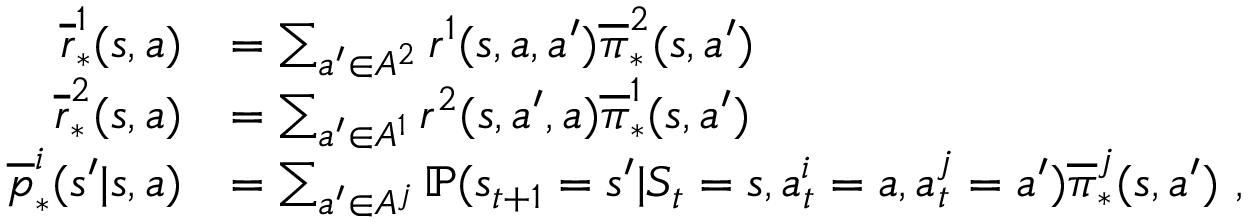<formula> <loc_0><loc_0><loc_500><loc_500>\begin{array} { r l } { \overline { r } _ { * } ^ { 1 } ( s , a ) } & { = \sum _ { a ^ { \prime } \in A ^ { 2 } } r ^ { 1 } ( s , a , a ^ { \prime } ) \overline { \pi } _ { * } ^ { 2 } ( s , a ^ { \prime } ) } \\ { \overline { r } _ { * } ^ { 2 } ( s , a ) } & { = \sum _ { a ^ { \prime } \in A ^ { 1 } } r ^ { 2 } ( s , a ^ { \prime } , a ) \overline { \pi } _ { * } ^ { 1 } ( s , a ^ { \prime } ) } \\ { \overline { p } _ { * } ^ { i } ( s ^ { \prime } | s , a ) } & { = \sum _ { a ^ { \prime } \in A ^ { j } } \mathbb { P } ( s _ { t + 1 } = s ^ { \prime } | S _ { t } = s , a _ { t } ^ { i } = a , a _ { t } ^ { j } = a ^ { \prime } ) \overline { \pi } _ { * } ^ { j } ( s , a ^ { \prime } ) \ , } \end{array}</formula> 